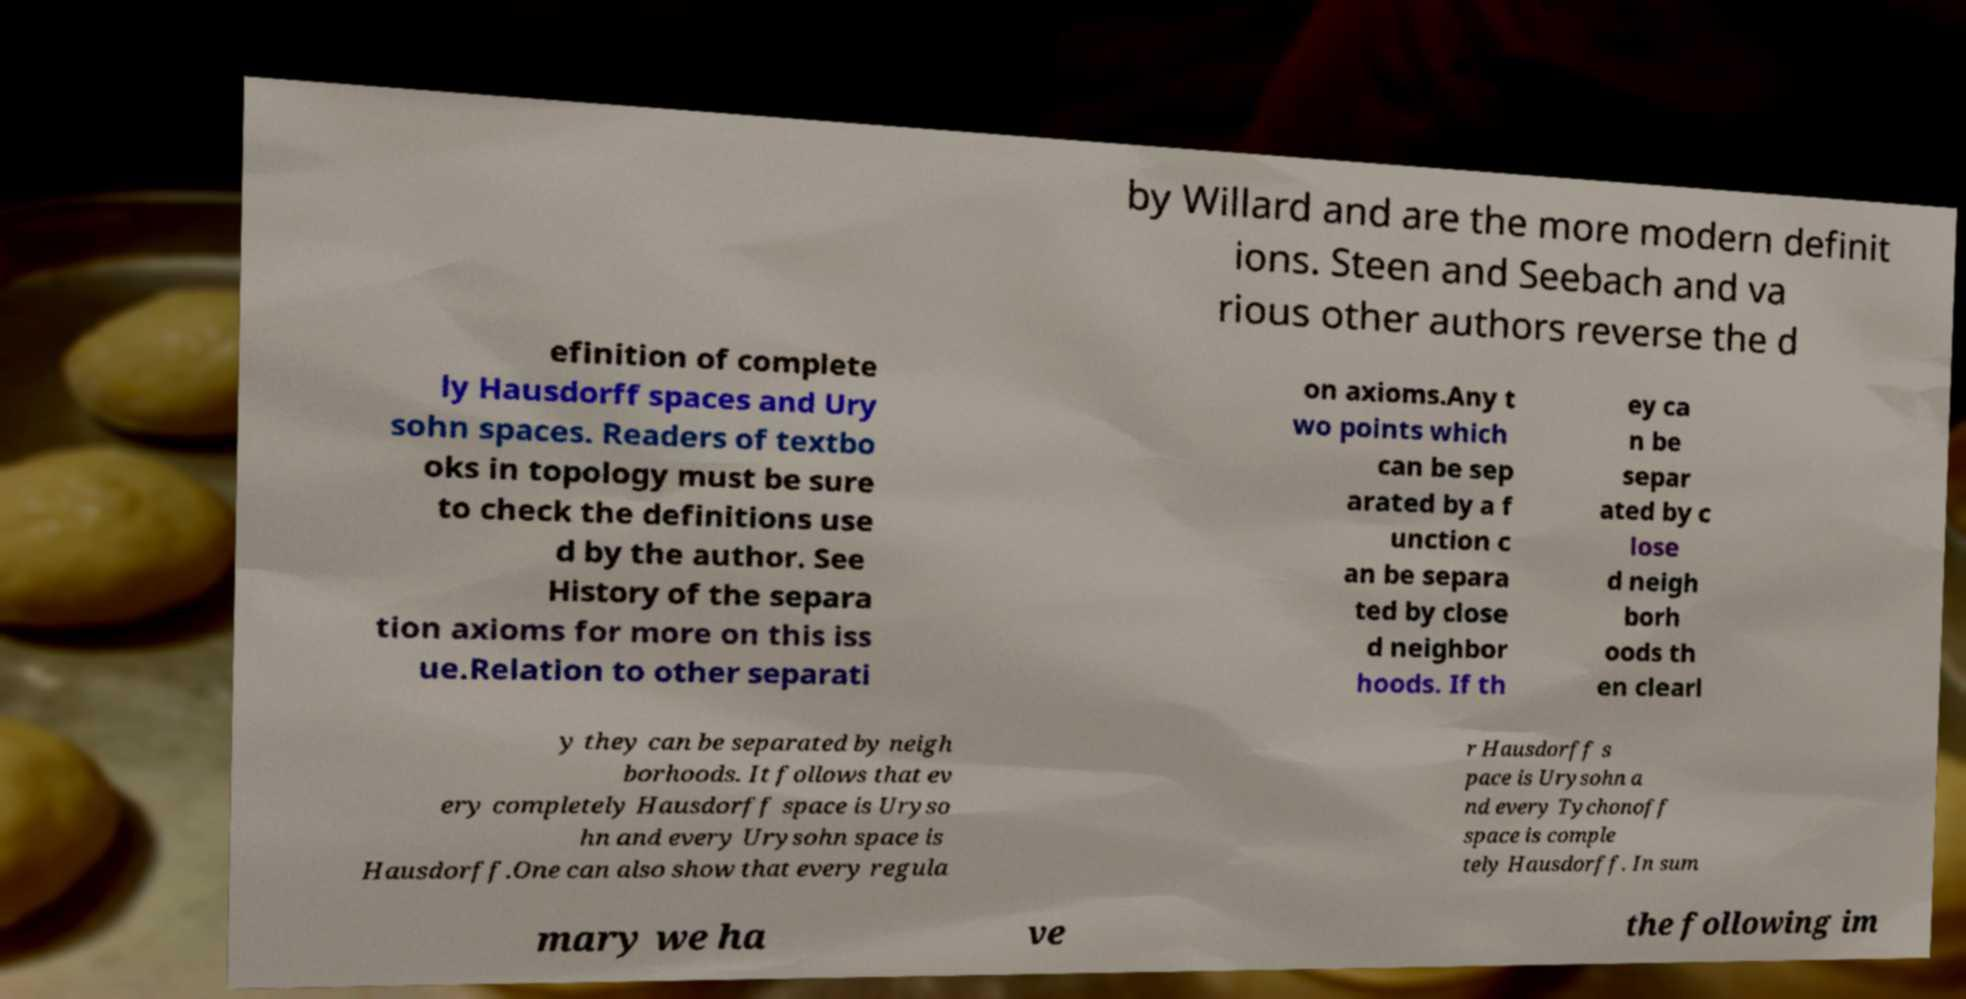Could you assist in decoding the text presented in this image and type it out clearly? by Willard and are the more modern definit ions. Steen and Seebach and va rious other authors reverse the d efinition of complete ly Hausdorff spaces and Ury sohn spaces. Readers of textbo oks in topology must be sure to check the definitions use d by the author. See History of the separa tion axioms for more on this iss ue.Relation to other separati on axioms.Any t wo points which can be sep arated by a f unction c an be separa ted by close d neighbor hoods. If th ey ca n be separ ated by c lose d neigh borh oods th en clearl y they can be separated by neigh borhoods. It follows that ev ery completely Hausdorff space is Uryso hn and every Urysohn space is Hausdorff.One can also show that every regula r Hausdorff s pace is Urysohn a nd every Tychonoff space is comple tely Hausdorff. In sum mary we ha ve the following im 